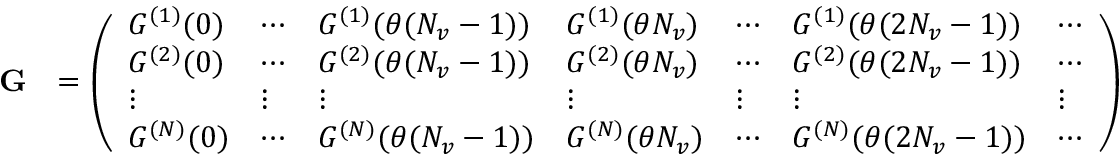Convert formula to latex. <formula><loc_0><loc_0><loc_500><loc_500>\begin{array} { r l } { G } & { = \left ( \begin{array} { l l l l l l l } { G ^ { ( 1 ) } ( 0 ) } & { \cdots } & { G ^ { ( 1 ) } ( \theta ( N _ { v } - 1 ) ) } & { G ^ { ( 1 ) } ( \theta N _ { v } ) } & { \cdots } & { G ^ { ( 1 ) } ( \theta ( 2 N _ { v } - 1 ) ) } & { \cdots } \\ { G ^ { ( 2 ) } ( 0 ) } & { \cdots } & { G ^ { ( 2 ) } ( \theta ( N _ { v } - 1 ) ) } & { G ^ { ( 2 ) } ( \theta N _ { v } ) } & { \cdots } & { G ^ { ( 2 ) } ( \theta ( 2 N _ { v } - 1 ) ) } & { \cdots } \\ { \vdots } & { \vdots } & { \vdots } & { \vdots } & { \vdots } & { \vdots } & { \vdots } \\ { G ^ { ( N ) } ( 0 ) } & { \cdots } & { G ^ { ( N ) } ( \theta ( N _ { v } - 1 ) ) } & { G ^ { ( N ) } ( \theta N _ { v } ) } & { \cdots } & { G ^ { ( N ) } ( \theta ( 2 N _ { v } - 1 ) ) } & { \cdots } \end{array} \right ) } \end{array}</formula> 